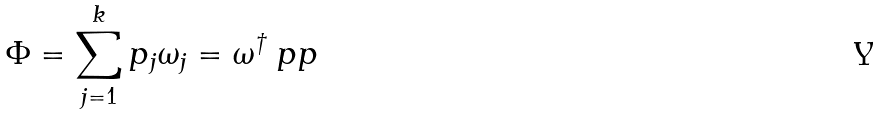Convert formula to latex. <formula><loc_0><loc_0><loc_500><loc_500>\Phi = \sum _ { j = 1 } ^ { k } p _ { j } \omega _ { j } = \omega ^ { \dag } \ p p</formula> 